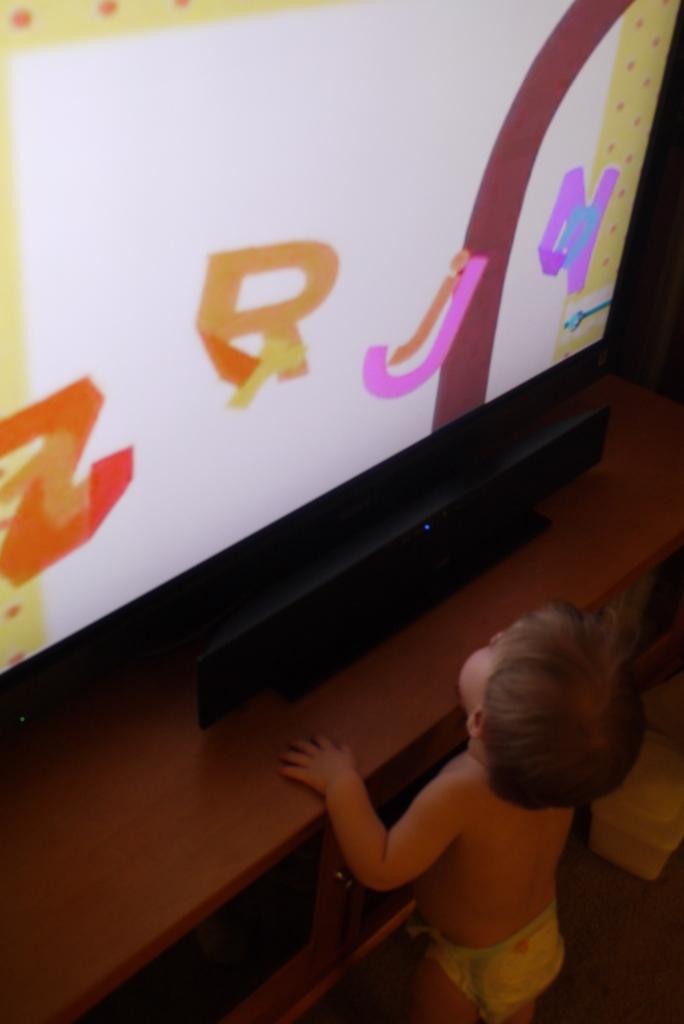Describe this image in one or two sentences. In this picture we can see a boy standing and holding table, on the table we can see television. 